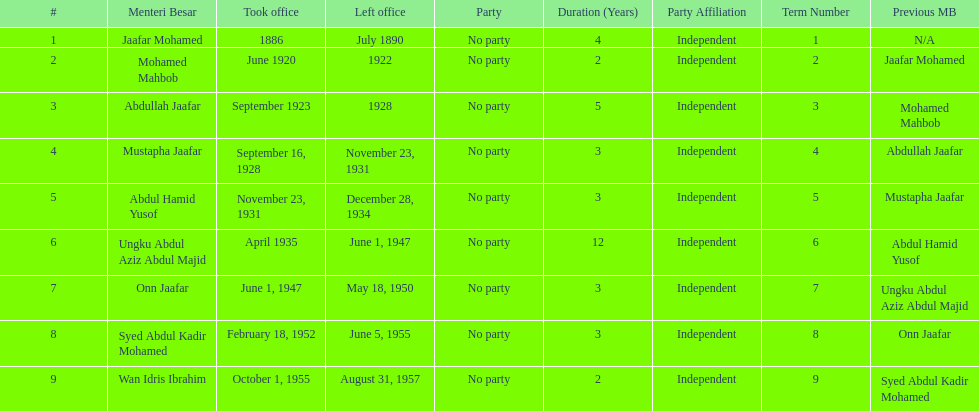Who were all of the menteri besars? Jaafar Mohamed, Mohamed Mahbob, Abdullah Jaafar, Mustapha Jaafar, Abdul Hamid Yusof, Ungku Abdul Aziz Abdul Majid, Onn Jaafar, Syed Abdul Kadir Mohamed, Wan Idris Ibrahim. When did they take office? 1886, June 1920, September 1923, September 16, 1928, November 23, 1931, April 1935, June 1, 1947, February 18, 1952, October 1, 1955. And when did they leave? July 1890, 1922, 1928, November 23, 1931, December 28, 1934, June 1, 1947, May 18, 1950, June 5, 1955, August 31, 1957. Now, who was in office for less than four years? Mohamed Mahbob. 